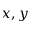Convert formula to latex. <formula><loc_0><loc_0><loc_500><loc_500>x , y</formula> 